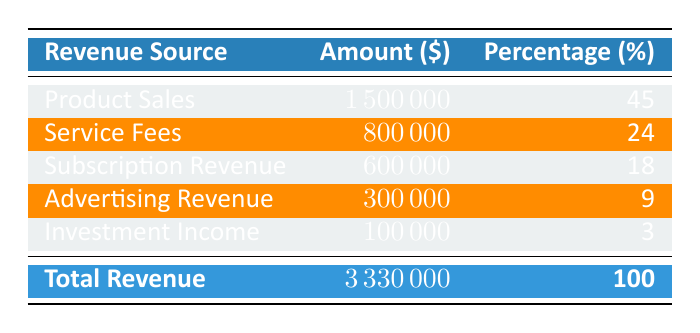What is the revenue amount from Product Sales? The table shows that the revenue amount from Product Sales is explicitly listed under the Amount column. It states that it is 1,500,000.
Answer: 1,500,000 What percentage of the total revenue is derived from Subscription Revenue? The table specifies that Subscription Revenue contributes 18% to the total revenue. This percentage is directly indicated in the Percentage column of the table.
Answer: 18% Is the total revenue greater than 3 million? The total revenue is stated at 3,330,000 in the table. Since 3,330,000 is indeed greater than 3 million, the answer is yes.
Answer: Yes How much less is the revenue from Advertising Revenue compared to Service Fees? To find the difference, we subtract the Advertising Revenue amount (300,000) from the Service Fees amount (800,000). The calculation is 800,000 - 300,000 = 500,000.
Answer: 500,000 What is the total amount of revenue from the first three sources combined? The first three sources listed are Product Sales, Service Fees, and Subscription Revenue, which have amounts of 1,500,000, 800,000, and 600,000 respectively. Adding these gives us 1,500,000 + 800,000 + 600,000 = 2,900,000.
Answer: 2,900,000 Is Investment Income the least contributing revenue source? In the table, Investment Income has the smallest revenue amount of 100,000 compared to the other sources, hence it is indeed the least contributing source.
Answer: Yes What proportion of the total revenue comes from the combination of Product Sales and Service Fees? First, we find the amounts for Product Sales (1,500,000) and Service Fees (800,000), which together sum to 1,500,000 + 800,000 = 2,300,000. Next, we calculate the proportion: (2,300,000 / 3,330,000) * 100% gives about 69%.
Answer: 69% Which revenue source has the highest percentage of contribution? The table clearly shows that Product Sales has the highest percentage at 45%, as indicated in the Percentage column.
Answer: 45% Calculate the average revenue amount from all sources. We first add together all revenue amounts: 1,500,000 + 800,000 + 600,000 + 300,000 + 100,000 = 3,330,000. We then divide by the number of sources, which is 5. Therefore, the average is 3,330,000 / 5 = 666,000.
Answer: 666,000 